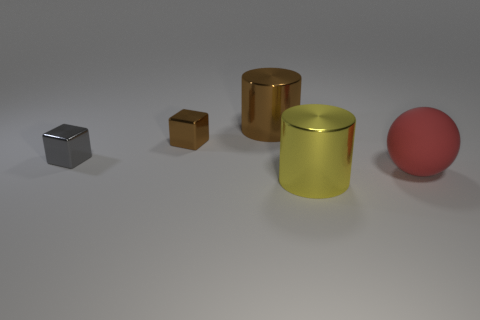Add 1 tiny gray shiny things. How many objects exist? 6 Subtract all cylinders. How many objects are left? 3 Add 2 rubber things. How many rubber things are left? 3 Add 3 small gray shiny objects. How many small gray shiny objects exist? 4 Subtract 0 purple blocks. How many objects are left? 5 Subtract all tiny gray objects. Subtract all shiny cylinders. How many objects are left? 2 